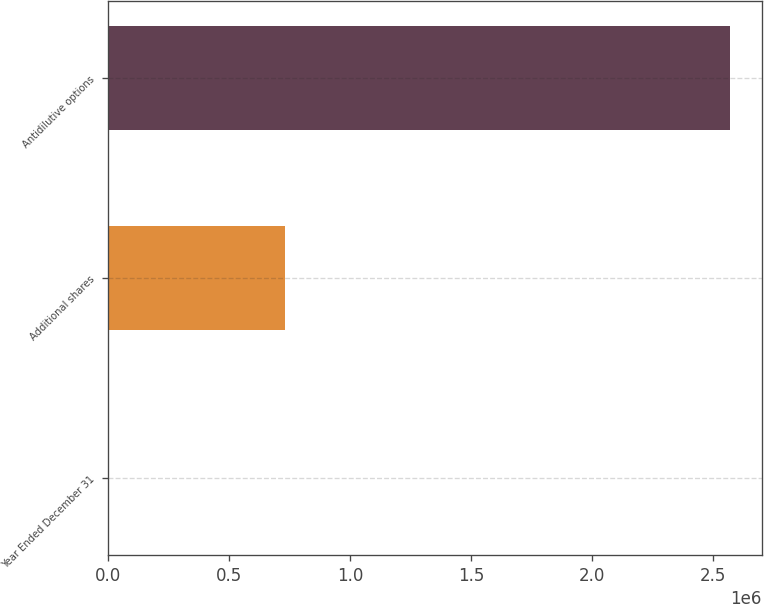Convert chart to OTSL. <chart><loc_0><loc_0><loc_500><loc_500><bar_chart><fcel>Year Ended December 31<fcel>Additional shares<fcel>Antidilutive options<nl><fcel>2012<fcel>730000<fcel>2.572e+06<nl></chart> 